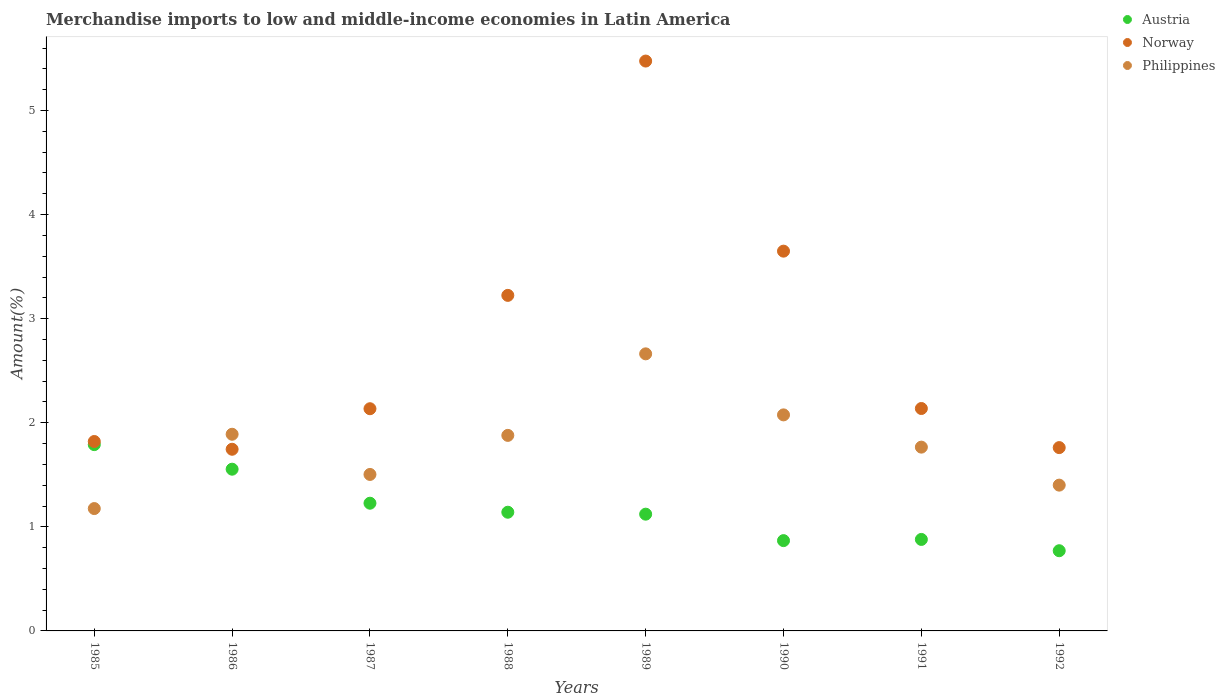Is the number of dotlines equal to the number of legend labels?
Make the answer very short. Yes. What is the percentage of amount earned from merchandise imports in Norway in 1987?
Offer a terse response. 2.13. Across all years, what is the maximum percentage of amount earned from merchandise imports in Philippines?
Offer a terse response. 2.66. Across all years, what is the minimum percentage of amount earned from merchandise imports in Austria?
Give a very brief answer. 0.77. In which year was the percentage of amount earned from merchandise imports in Philippines minimum?
Ensure brevity in your answer.  1985. What is the total percentage of amount earned from merchandise imports in Austria in the graph?
Ensure brevity in your answer.  9.35. What is the difference between the percentage of amount earned from merchandise imports in Norway in 1986 and that in 1990?
Make the answer very short. -1.9. What is the difference between the percentage of amount earned from merchandise imports in Norway in 1985 and the percentage of amount earned from merchandise imports in Philippines in 1988?
Make the answer very short. -0.06. What is the average percentage of amount earned from merchandise imports in Austria per year?
Offer a very short reply. 1.17. In the year 1985, what is the difference between the percentage of amount earned from merchandise imports in Philippines and percentage of amount earned from merchandise imports in Norway?
Offer a very short reply. -0.64. What is the ratio of the percentage of amount earned from merchandise imports in Philippines in 1985 to that in 1992?
Offer a very short reply. 0.84. Is the percentage of amount earned from merchandise imports in Philippines in 1985 less than that in 1988?
Your answer should be compact. Yes. Is the difference between the percentage of amount earned from merchandise imports in Philippines in 1987 and 1990 greater than the difference between the percentage of amount earned from merchandise imports in Norway in 1987 and 1990?
Give a very brief answer. Yes. What is the difference between the highest and the second highest percentage of amount earned from merchandise imports in Philippines?
Provide a short and direct response. 0.59. What is the difference between the highest and the lowest percentage of amount earned from merchandise imports in Norway?
Your answer should be compact. 3.73. Is the sum of the percentage of amount earned from merchandise imports in Austria in 1986 and 1988 greater than the maximum percentage of amount earned from merchandise imports in Philippines across all years?
Give a very brief answer. Yes. Does the percentage of amount earned from merchandise imports in Norway monotonically increase over the years?
Offer a very short reply. No. Is the percentage of amount earned from merchandise imports in Philippines strictly greater than the percentage of amount earned from merchandise imports in Norway over the years?
Provide a short and direct response. No. Is the percentage of amount earned from merchandise imports in Austria strictly less than the percentage of amount earned from merchandise imports in Norway over the years?
Give a very brief answer. Yes. Are the values on the major ticks of Y-axis written in scientific E-notation?
Provide a succinct answer. No. Where does the legend appear in the graph?
Your answer should be compact. Top right. How many legend labels are there?
Ensure brevity in your answer.  3. What is the title of the graph?
Make the answer very short. Merchandise imports to low and middle-income economies in Latin America. Does "Swaziland" appear as one of the legend labels in the graph?
Make the answer very short. No. What is the label or title of the X-axis?
Keep it short and to the point. Years. What is the label or title of the Y-axis?
Offer a very short reply. Amount(%). What is the Amount(%) in Austria in 1985?
Make the answer very short. 1.79. What is the Amount(%) of Norway in 1985?
Offer a very short reply. 1.82. What is the Amount(%) in Philippines in 1985?
Ensure brevity in your answer.  1.18. What is the Amount(%) of Austria in 1986?
Ensure brevity in your answer.  1.55. What is the Amount(%) in Norway in 1986?
Provide a succinct answer. 1.75. What is the Amount(%) of Philippines in 1986?
Provide a short and direct response. 1.89. What is the Amount(%) of Austria in 1987?
Your answer should be compact. 1.23. What is the Amount(%) of Norway in 1987?
Provide a short and direct response. 2.13. What is the Amount(%) of Philippines in 1987?
Your answer should be compact. 1.5. What is the Amount(%) in Austria in 1988?
Give a very brief answer. 1.14. What is the Amount(%) of Norway in 1988?
Offer a terse response. 3.22. What is the Amount(%) of Philippines in 1988?
Give a very brief answer. 1.88. What is the Amount(%) in Austria in 1989?
Your answer should be very brief. 1.12. What is the Amount(%) of Norway in 1989?
Make the answer very short. 5.48. What is the Amount(%) of Philippines in 1989?
Your answer should be very brief. 2.66. What is the Amount(%) in Austria in 1990?
Offer a terse response. 0.87. What is the Amount(%) of Norway in 1990?
Your answer should be compact. 3.65. What is the Amount(%) of Philippines in 1990?
Ensure brevity in your answer.  2.08. What is the Amount(%) in Austria in 1991?
Offer a terse response. 0.88. What is the Amount(%) in Norway in 1991?
Offer a very short reply. 2.14. What is the Amount(%) in Philippines in 1991?
Your answer should be compact. 1.77. What is the Amount(%) of Austria in 1992?
Offer a terse response. 0.77. What is the Amount(%) of Norway in 1992?
Make the answer very short. 1.76. What is the Amount(%) in Philippines in 1992?
Provide a short and direct response. 1.4. Across all years, what is the maximum Amount(%) in Austria?
Give a very brief answer. 1.79. Across all years, what is the maximum Amount(%) of Norway?
Your answer should be very brief. 5.48. Across all years, what is the maximum Amount(%) of Philippines?
Ensure brevity in your answer.  2.66. Across all years, what is the minimum Amount(%) of Austria?
Give a very brief answer. 0.77. Across all years, what is the minimum Amount(%) of Norway?
Provide a short and direct response. 1.75. Across all years, what is the minimum Amount(%) in Philippines?
Provide a short and direct response. 1.18. What is the total Amount(%) of Austria in the graph?
Your response must be concise. 9.35. What is the total Amount(%) in Norway in the graph?
Keep it short and to the point. 21.95. What is the total Amount(%) of Philippines in the graph?
Your answer should be compact. 14.35. What is the difference between the Amount(%) of Austria in 1985 and that in 1986?
Your response must be concise. 0.24. What is the difference between the Amount(%) in Norway in 1985 and that in 1986?
Offer a terse response. 0.07. What is the difference between the Amount(%) of Philippines in 1985 and that in 1986?
Offer a very short reply. -0.71. What is the difference between the Amount(%) of Austria in 1985 and that in 1987?
Offer a terse response. 0.56. What is the difference between the Amount(%) in Norway in 1985 and that in 1987?
Keep it short and to the point. -0.31. What is the difference between the Amount(%) of Philippines in 1985 and that in 1987?
Provide a succinct answer. -0.33. What is the difference between the Amount(%) in Austria in 1985 and that in 1988?
Your answer should be compact. 0.65. What is the difference between the Amount(%) of Norway in 1985 and that in 1988?
Ensure brevity in your answer.  -1.4. What is the difference between the Amount(%) in Philippines in 1985 and that in 1988?
Offer a terse response. -0.7. What is the difference between the Amount(%) of Austria in 1985 and that in 1989?
Offer a terse response. 0.67. What is the difference between the Amount(%) in Norway in 1985 and that in 1989?
Offer a very short reply. -3.66. What is the difference between the Amount(%) of Philippines in 1985 and that in 1989?
Offer a very short reply. -1.49. What is the difference between the Amount(%) of Austria in 1985 and that in 1990?
Give a very brief answer. 0.92. What is the difference between the Amount(%) of Norway in 1985 and that in 1990?
Offer a very short reply. -1.83. What is the difference between the Amount(%) of Philippines in 1985 and that in 1990?
Ensure brevity in your answer.  -0.9. What is the difference between the Amount(%) in Austria in 1985 and that in 1991?
Provide a succinct answer. 0.91. What is the difference between the Amount(%) in Norway in 1985 and that in 1991?
Make the answer very short. -0.32. What is the difference between the Amount(%) of Philippines in 1985 and that in 1991?
Offer a very short reply. -0.59. What is the difference between the Amount(%) in Austria in 1985 and that in 1992?
Offer a very short reply. 1.02. What is the difference between the Amount(%) in Norway in 1985 and that in 1992?
Keep it short and to the point. 0.06. What is the difference between the Amount(%) in Philippines in 1985 and that in 1992?
Provide a succinct answer. -0.23. What is the difference between the Amount(%) of Austria in 1986 and that in 1987?
Your answer should be compact. 0.33. What is the difference between the Amount(%) in Norway in 1986 and that in 1987?
Provide a succinct answer. -0.39. What is the difference between the Amount(%) in Philippines in 1986 and that in 1987?
Your answer should be very brief. 0.39. What is the difference between the Amount(%) of Austria in 1986 and that in 1988?
Give a very brief answer. 0.41. What is the difference between the Amount(%) of Norway in 1986 and that in 1988?
Keep it short and to the point. -1.48. What is the difference between the Amount(%) in Philippines in 1986 and that in 1988?
Make the answer very short. 0.01. What is the difference between the Amount(%) in Austria in 1986 and that in 1989?
Give a very brief answer. 0.43. What is the difference between the Amount(%) in Norway in 1986 and that in 1989?
Provide a succinct answer. -3.73. What is the difference between the Amount(%) of Philippines in 1986 and that in 1989?
Ensure brevity in your answer.  -0.77. What is the difference between the Amount(%) of Austria in 1986 and that in 1990?
Offer a terse response. 0.69. What is the difference between the Amount(%) in Norway in 1986 and that in 1990?
Your answer should be very brief. -1.9. What is the difference between the Amount(%) of Philippines in 1986 and that in 1990?
Your answer should be very brief. -0.19. What is the difference between the Amount(%) in Austria in 1986 and that in 1991?
Make the answer very short. 0.67. What is the difference between the Amount(%) in Norway in 1986 and that in 1991?
Keep it short and to the point. -0.39. What is the difference between the Amount(%) of Philippines in 1986 and that in 1991?
Provide a succinct answer. 0.12. What is the difference between the Amount(%) in Austria in 1986 and that in 1992?
Offer a very short reply. 0.78. What is the difference between the Amount(%) of Norway in 1986 and that in 1992?
Give a very brief answer. -0.02. What is the difference between the Amount(%) of Philippines in 1986 and that in 1992?
Keep it short and to the point. 0.49. What is the difference between the Amount(%) of Austria in 1987 and that in 1988?
Ensure brevity in your answer.  0.09. What is the difference between the Amount(%) in Norway in 1987 and that in 1988?
Ensure brevity in your answer.  -1.09. What is the difference between the Amount(%) of Philippines in 1987 and that in 1988?
Your response must be concise. -0.38. What is the difference between the Amount(%) of Austria in 1987 and that in 1989?
Ensure brevity in your answer.  0.11. What is the difference between the Amount(%) of Norway in 1987 and that in 1989?
Give a very brief answer. -3.34. What is the difference between the Amount(%) of Philippines in 1987 and that in 1989?
Ensure brevity in your answer.  -1.16. What is the difference between the Amount(%) in Austria in 1987 and that in 1990?
Provide a short and direct response. 0.36. What is the difference between the Amount(%) of Norway in 1987 and that in 1990?
Offer a very short reply. -1.51. What is the difference between the Amount(%) of Philippines in 1987 and that in 1990?
Provide a short and direct response. -0.57. What is the difference between the Amount(%) of Austria in 1987 and that in 1991?
Your response must be concise. 0.35. What is the difference between the Amount(%) of Norway in 1987 and that in 1991?
Keep it short and to the point. -0. What is the difference between the Amount(%) of Philippines in 1987 and that in 1991?
Keep it short and to the point. -0.26. What is the difference between the Amount(%) of Austria in 1987 and that in 1992?
Offer a terse response. 0.46. What is the difference between the Amount(%) in Norway in 1987 and that in 1992?
Ensure brevity in your answer.  0.37. What is the difference between the Amount(%) in Philippines in 1987 and that in 1992?
Provide a succinct answer. 0.1. What is the difference between the Amount(%) of Austria in 1988 and that in 1989?
Provide a short and direct response. 0.02. What is the difference between the Amount(%) in Norway in 1988 and that in 1989?
Offer a terse response. -2.25. What is the difference between the Amount(%) of Philippines in 1988 and that in 1989?
Your response must be concise. -0.78. What is the difference between the Amount(%) of Austria in 1988 and that in 1990?
Provide a short and direct response. 0.27. What is the difference between the Amount(%) of Norway in 1988 and that in 1990?
Your answer should be compact. -0.42. What is the difference between the Amount(%) of Philippines in 1988 and that in 1990?
Offer a very short reply. -0.2. What is the difference between the Amount(%) in Austria in 1988 and that in 1991?
Give a very brief answer. 0.26. What is the difference between the Amount(%) in Norway in 1988 and that in 1991?
Provide a short and direct response. 1.09. What is the difference between the Amount(%) of Philippines in 1988 and that in 1991?
Provide a short and direct response. 0.11. What is the difference between the Amount(%) in Austria in 1988 and that in 1992?
Give a very brief answer. 0.37. What is the difference between the Amount(%) in Norway in 1988 and that in 1992?
Keep it short and to the point. 1.46. What is the difference between the Amount(%) of Philippines in 1988 and that in 1992?
Your answer should be compact. 0.48. What is the difference between the Amount(%) of Austria in 1989 and that in 1990?
Your answer should be compact. 0.25. What is the difference between the Amount(%) in Norway in 1989 and that in 1990?
Your answer should be very brief. 1.83. What is the difference between the Amount(%) in Philippines in 1989 and that in 1990?
Ensure brevity in your answer.  0.59. What is the difference between the Amount(%) of Austria in 1989 and that in 1991?
Keep it short and to the point. 0.24. What is the difference between the Amount(%) in Norway in 1989 and that in 1991?
Your response must be concise. 3.34. What is the difference between the Amount(%) in Philippines in 1989 and that in 1991?
Make the answer very short. 0.9. What is the difference between the Amount(%) of Austria in 1989 and that in 1992?
Your answer should be compact. 0.35. What is the difference between the Amount(%) in Norway in 1989 and that in 1992?
Your answer should be very brief. 3.71. What is the difference between the Amount(%) of Philippines in 1989 and that in 1992?
Your response must be concise. 1.26. What is the difference between the Amount(%) in Austria in 1990 and that in 1991?
Offer a very short reply. -0.01. What is the difference between the Amount(%) in Norway in 1990 and that in 1991?
Your answer should be compact. 1.51. What is the difference between the Amount(%) of Philippines in 1990 and that in 1991?
Ensure brevity in your answer.  0.31. What is the difference between the Amount(%) in Austria in 1990 and that in 1992?
Ensure brevity in your answer.  0.1. What is the difference between the Amount(%) of Norway in 1990 and that in 1992?
Your answer should be compact. 1.89. What is the difference between the Amount(%) of Philippines in 1990 and that in 1992?
Offer a very short reply. 0.68. What is the difference between the Amount(%) in Austria in 1991 and that in 1992?
Offer a very short reply. 0.11. What is the difference between the Amount(%) in Norway in 1991 and that in 1992?
Your answer should be very brief. 0.38. What is the difference between the Amount(%) of Philippines in 1991 and that in 1992?
Offer a terse response. 0.37. What is the difference between the Amount(%) of Austria in 1985 and the Amount(%) of Norway in 1986?
Offer a very short reply. 0.04. What is the difference between the Amount(%) of Austria in 1985 and the Amount(%) of Philippines in 1986?
Provide a succinct answer. -0.1. What is the difference between the Amount(%) in Norway in 1985 and the Amount(%) in Philippines in 1986?
Keep it short and to the point. -0.07. What is the difference between the Amount(%) in Austria in 1985 and the Amount(%) in Norway in 1987?
Your response must be concise. -0.34. What is the difference between the Amount(%) in Austria in 1985 and the Amount(%) in Philippines in 1987?
Keep it short and to the point. 0.29. What is the difference between the Amount(%) of Norway in 1985 and the Amount(%) of Philippines in 1987?
Your answer should be very brief. 0.32. What is the difference between the Amount(%) in Austria in 1985 and the Amount(%) in Norway in 1988?
Ensure brevity in your answer.  -1.43. What is the difference between the Amount(%) in Austria in 1985 and the Amount(%) in Philippines in 1988?
Make the answer very short. -0.09. What is the difference between the Amount(%) of Norway in 1985 and the Amount(%) of Philippines in 1988?
Provide a succinct answer. -0.06. What is the difference between the Amount(%) in Austria in 1985 and the Amount(%) in Norway in 1989?
Offer a terse response. -3.69. What is the difference between the Amount(%) of Austria in 1985 and the Amount(%) of Philippines in 1989?
Offer a terse response. -0.87. What is the difference between the Amount(%) in Norway in 1985 and the Amount(%) in Philippines in 1989?
Your answer should be compact. -0.84. What is the difference between the Amount(%) of Austria in 1985 and the Amount(%) of Norway in 1990?
Offer a terse response. -1.86. What is the difference between the Amount(%) of Austria in 1985 and the Amount(%) of Philippines in 1990?
Keep it short and to the point. -0.29. What is the difference between the Amount(%) in Norway in 1985 and the Amount(%) in Philippines in 1990?
Ensure brevity in your answer.  -0.26. What is the difference between the Amount(%) of Austria in 1985 and the Amount(%) of Norway in 1991?
Make the answer very short. -0.35. What is the difference between the Amount(%) in Austria in 1985 and the Amount(%) in Philippines in 1991?
Your response must be concise. 0.02. What is the difference between the Amount(%) in Norway in 1985 and the Amount(%) in Philippines in 1991?
Your answer should be very brief. 0.05. What is the difference between the Amount(%) in Austria in 1985 and the Amount(%) in Norway in 1992?
Provide a short and direct response. 0.03. What is the difference between the Amount(%) of Austria in 1985 and the Amount(%) of Philippines in 1992?
Make the answer very short. 0.39. What is the difference between the Amount(%) in Norway in 1985 and the Amount(%) in Philippines in 1992?
Offer a terse response. 0.42. What is the difference between the Amount(%) of Austria in 1986 and the Amount(%) of Norway in 1987?
Make the answer very short. -0.58. What is the difference between the Amount(%) in Austria in 1986 and the Amount(%) in Philippines in 1987?
Keep it short and to the point. 0.05. What is the difference between the Amount(%) of Norway in 1986 and the Amount(%) of Philippines in 1987?
Provide a short and direct response. 0.24. What is the difference between the Amount(%) in Austria in 1986 and the Amount(%) in Norway in 1988?
Offer a terse response. -1.67. What is the difference between the Amount(%) in Austria in 1986 and the Amount(%) in Philippines in 1988?
Keep it short and to the point. -0.32. What is the difference between the Amount(%) in Norway in 1986 and the Amount(%) in Philippines in 1988?
Give a very brief answer. -0.13. What is the difference between the Amount(%) in Austria in 1986 and the Amount(%) in Norway in 1989?
Your answer should be compact. -3.92. What is the difference between the Amount(%) of Austria in 1986 and the Amount(%) of Philippines in 1989?
Provide a succinct answer. -1.11. What is the difference between the Amount(%) of Norway in 1986 and the Amount(%) of Philippines in 1989?
Keep it short and to the point. -0.92. What is the difference between the Amount(%) of Austria in 1986 and the Amount(%) of Norway in 1990?
Provide a short and direct response. -2.09. What is the difference between the Amount(%) of Austria in 1986 and the Amount(%) of Philippines in 1990?
Provide a short and direct response. -0.52. What is the difference between the Amount(%) of Norway in 1986 and the Amount(%) of Philippines in 1990?
Ensure brevity in your answer.  -0.33. What is the difference between the Amount(%) of Austria in 1986 and the Amount(%) of Norway in 1991?
Provide a succinct answer. -0.58. What is the difference between the Amount(%) of Austria in 1986 and the Amount(%) of Philippines in 1991?
Offer a very short reply. -0.21. What is the difference between the Amount(%) of Norway in 1986 and the Amount(%) of Philippines in 1991?
Make the answer very short. -0.02. What is the difference between the Amount(%) in Austria in 1986 and the Amount(%) in Norway in 1992?
Provide a succinct answer. -0.21. What is the difference between the Amount(%) in Austria in 1986 and the Amount(%) in Philippines in 1992?
Ensure brevity in your answer.  0.15. What is the difference between the Amount(%) in Norway in 1986 and the Amount(%) in Philippines in 1992?
Keep it short and to the point. 0.34. What is the difference between the Amount(%) in Austria in 1987 and the Amount(%) in Norway in 1988?
Your answer should be compact. -2. What is the difference between the Amount(%) of Austria in 1987 and the Amount(%) of Philippines in 1988?
Keep it short and to the point. -0.65. What is the difference between the Amount(%) in Norway in 1987 and the Amount(%) in Philippines in 1988?
Make the answer very short. 0.26. What is the difference between the Amount(%) of Austria in 1987 and the Amount(%) of Norway in 1989?
Your answer should be very brief. -4.25. What is the difference between the Amount(%) of Austria in 1987 and the Amount(%) of Philippines in 1989?
Provide a short and direct response. -1.44. What is the difference between the Amount(%) in Norway in 1987 and the Amount(%) in Philippines in 1989?
Your answer should be very brief. -0.53. What is the difference between the Amount(%) of Austria in 1987 and the Amount(%) of Norway in 1990?
Give a very brief answer. -2.42. What is the difference between the Amount(%) in Austria in 1987 and the Amount(%) in Philippines in 1990?
Give a very brief answer. -0.85. What is the difference between the Amount(%) in Norway in 1987 and the Amount(%) in Philippines in 1990?
Offer a very short reply. 0.06. What is the difference between the Amount(%) in Austria in 1987 and the Amount(%) in Norway in 1991?
Offer a very short reply. -0.91. What is the difference between the Amount(%) in Austria in 1987 and the Amount(%) in Philippines in 1991?
Provide a short and direct response. -0.54. What is the difference between the Amount(%) in Norway in 1987 and the Amount(%) in Philippines in 1991?
Ensure brevity in your answer.  0.37. What is the difference between the Amount(%) of Austria in 1987 and the Amount(%) of Norway in 1992?
Provide a succinct answer. -0.53. What is the difference between the Amount(%) in Austria in 1987 and the Amount(%) in Philippines in 1992?
Your answer should be very brief. -0.17. What is the difference between the Amount(%) of Norway in 1987 and the Amount(%) of Philippines in 1992?
Offer a terse response. 0.73. What is the difference between the Amount(%) in Austria in 1988 and the Amount(%) in Norway in 1989?
Ensure brevity in your answer.  -4.33. What is the difference between the Amount(%) of Austria in 1988 and the Amount(%) of Philippines in 1989?
Make the answer very short. -1.52. What is the difference between the Amount(%) of Norway in 1988 and the Amount(%) of Philippines in 1989?
Make the answer very short. 0.56. What is the difference between the Amount(%) in Austria in 1988 and the Amount(%) in Norway in 1990?
Give a very brief answer. -2.51. What is the difference between the Amount(%) of Austria in 1988 and the Amount(%) of Philippines in 1990?
Offer a very short reply. -0.94. What is the difference between the Amount(%) of Norway in 1988 and the Amount(%) of Philippines in 1990?
Your response must be concise. 1.15. What is the difference between the Amount(%) in Austria in 1988 and the Amount(%) in Norway in 1991?
Give a very brief answer. -1. What is the difference between the Amount(%) in Austria in 1988 and the Amount(%) in Philippines in 1991?
Give a very brief answer. -0.63. What is the difference between the Amount(%) in Norway in 1988 and the Amount(%) in Philippines in 1991?
Offer a terse response. 1.46. What is the difference between the Amount(%) of Austria in 1988 and the Amount(%) of Norway in 1992?
Your answer should be compact. -0.62. What is the difference between the Amount(%) in Austria in 1988 and the Amount(%) in Philippines in 1992?
Ensure brevity in your answer.  -0.26. What is the difference between the Amount(%) in Norway in 1988 and the Amount(%) in Philippines in 1992?
Your answer should be compact. 1.82. What is the difference between the Amount(%) of Austria in 1989 and the Amount(%) of Norway in 1990?
Make the answer very short. -2.53. What is the difference between the Amount(%) of Austria in 1989 and the Amount(%) of Philippines in 1990?
Offer a very short reply. -0.95. What is the difference between the Amount(%) in Norway in 1989 and the Amount(%) in Philippines in 1990?
Provide a short and direct response. 3.4. What is the difference between the Amount(%) of Austria in 1989 and the Amount(%) of Norway in 1991?
Ensure brevity in your answer.  -1.02. What is the difference between the Amount(%) in Austria in 1989 and the Amount(%) in Philippines in 1991?
Your response must be concise. -0.64. What is the difference between the Amount(%) of Norway in 1989 and the Amount(%) of Philippines in 1991?
Offer a very short reply. 3.71. What is the difference between the Amount(%) in Austria in 1989 and the Amount(%) in Norway in 1992?
Your response must be concise. -0.64. What is the difference between the Amount(%) in Austria in 1989 and the Amount(%) in Philippines in 1992?
Keep it short and to the point. -0.28. What is the difference between the Amount(%) of Norway in 1989 and the Amount(%) of Philippines in 1992?
Ensure brevity in your answer.  4.07. What is the difference between the Amount(%) of Austria in 1990 and the Amount(%) of Norway in 1991?
Keep it short and to the point. -1.27. What is the difference between the Amount(%) of Austria in 1990 and the Amount(%) of Philippines in 1991?
Keep it short and to the point. -0.9. What is the difference between the Amount(%) in Norway in 1990 and the Amount(%) in Philippines in 1991?
Your answer should be compact. 1.88. What is the difference between the Amount(%) in Austria in 1990 and the Amount(%) in Norway in 1992?
Provide a short and direct response. -0.89. What is the difference between the Amount(%) in Austria in 1990 and the Amount(%) in Philippines in 1992?
Keep it short and to the point. -0.53. What is the difference between the Amount(%) of Norway in 1990 and the Amount(%) of Philippines in 1992?
Make the answer very short. 2.25. What is the difference between the Amount(%) of Austria in 1991 and the Amount(%) of Norway in 1992?
Your response must be concise. -0.88. What is the difference between the Amount(%) of Austria in 1991 and the Amount(%) of Philippines in 1992?
Provide a short and direct response. -0.52. What is the difference between the Amount(%) in Norway in 1991 and the Amount(%) in Philippines in 1992?
Your answer should be compact. 0.74. What is the average Amount(%) of Austria per year?
Your answer should be very brief. 1.17. What is the average Amount(%) in Norway per year?
Provide a succinct answer. 2.74. What is the average Amount(%) in Philippines per year?
Offer a terse response. 1.79. In the year 1985, what is the difference between the Amount(%) in Austria and Amount(%) in Norway?
Offer a very short reply. -0.03. In the year 1985, what is the difference between the Amount(%) of Austria and Amount(%) of Philippines?
Provide a succinct answer. 0.61. In the year 1985, what is the difference between the Amount(%) of Norway and Amount(%) of Philippines?
Your response must be concise. 0.64. In the year 1986, what is the difference between the Amount(%) in Austria and Amount(%) in Norway?
Make the answer very short. -0.19. In the year 1986, what is the difference between the Amount(%) in Austria and Amount(%) in Philippines?
Give a very brief answer. -0.34. In the year 1986, what is the difference between the Amount(%) in Norway and Amount(%) in Philippines?
Your answer should be compact. -0.14. In the year 1987, what is the difference between the Amount(%) of Austria and Amount(%) of Norway?
Offer a very short reply. -0.91. In the year 1987, what is the difference between the Amount(%) of Austria and Amount(%) of Philippines?
Offer a terse response. -0.28. In the year 1987, what is the difference between the Amount(%) in Norway and Amount(%) in Philippines?
Your answer should be compact. 0.63. In the year 1988, what is the difference between the Amount(%) of Austria and Amount(%) of Norway?
Make the answer very short. -2.08. In the year 1988, what is the difference between the Amount(%) of Austria and Amount(%) of Philippines?
Offer a very short reply. -0.74. In the year 1988, what is the difference between the Amount(%) of Norway and Amount(%) of Philippines?
Offer a terse response. 1.35. In the year 1989, what is the difference between the Amount(%) in Austria and Amount(%) in Norway?
Make the answer very short. -4.35. In the year 1989, what is the difference between the Amount(%) of Austria and Amount(%) of Philippines?
Your answer should be compact. -1.54. In the year 1989, what is the difference between the Amount(%) of Norway and Amount(%) of Philippines?
Your answer should be very brief. 2.81. In the year 1990, what is the difference between the Amount(%) of Austria and Amount(%) of Norway?
Your answer should be compact. -2.78. In the year 1990, what is the difference between the Amount(%) in Austria and Amount(%) in Philippines?
Offer a terse response. -1.21. In the year 1990, what is the difference between the Amount(%) of Norway and Amount(%) of Philippines?
Provide a succinct answer. 1.57. In the year 1991, what is the difference between the Amount(%) of Austria and Amount(%) of Norway?
Your answer should be very brief. -1.26. In the year 1991, what is the difference between the Amount(%) of Austria and Amount(%) of Philippines?
Ensure brevity in your answer.  -0.89. In the year 1991, what is the difference between the Amount(%) in Norway and Amount(%) in Philippines?
Your response must be concise. 0.37. In the year 1992, what is the difference between the Amount(%) in Austria and Amount(%) in Norway?
Your answer should be very brief. -0.99. In the year 1992, what is the difference between the Amount(%) of Austria and Amount(%) of Philippines?
Your answer should be compact. -0.63. In the year 1992, what is the difference between the Amount(%) in Norway and Amount(%) in Philippines?
Offer a terse response. 0.36. What is the ratio of the Amount(%) of Austria in 1985 to that in 1986?
Provide a short and direct response. 1.15. What is the ratio of the Amount(%) in Norway in 1985 to that in 1986?
Keep it short and to the point. 1.04. What is the ratio of the Amount(%) in Philippines in 1985 to that in 1986?
Your response must be concise. 0.62. What is the ratio of the Amount(%) of Austria in 1985 to that in 1987?
Your response must be concise. 1.46. What is the ratio of the Amount(%) in Norway in 1985 to that in 1987?
Your response must be concise. 0.85. What is the ratio of the Amount(%) of Philippines in 1985 to that in 1987?
Offer a very short reply. 0.78. What is the ratio of the Amount(%) of Austria in 1985 to that in 1988?
Your answer should be compact. 1.57. What is the ratio of the Amount(%) in Norway in 1985 to that in 1988?
Offer a very short reply. 0.56. What is the ratio of the Amount(%) of Philippines in 1985 to that in 1988?
Ensure brevity in your answer.  0.63. What is the ratio of the Amount(%) in Austria in 1985 to that in 1989?
Keep it short and to the point. 1.6. What is the ratio of the Amount(%) of Norway in 1985 to that in 1989?
Keep it short and to the point. 0.33. What is the ratio of the Amount(%) of Philippines in 1985 to that in 1989?
Keep it short and to the point. 0.44. What is the ratio of the Amount(%) in Austria in 1985 to that in 1990?
Offer a terse response. 2.06. What is the ratio of the Amount(%) in Norway in 1985 to that in 1990?
Your answer should be compact. 0.5. What is the ratio of the Amount(%) of Philippines in 1985 to that in 1990?
Give a very brief answer. 0.57. What is the ratio of the Amount(%) of Austria in 1985 to that in 1991?
Your answer should be very brief. 2.04. What is the ratio of the Amount(%) in Norway in 1985 to that in 1991?
Make the answer very short. 0.85. What is the ratio of the Amount(%) of Philippines in 1985 to that in 1991?
Offer a terse response. 0.67. What is the ratio of the Amount(%) in Austria in 1985 to that in 1992?
Your response must be concise. 2.32. What is the ratio of the Amount(%) of Philippines in 1985 to that in 1992?
Your answer should be very brief. 0.84. What is the ratio of the Amount(%) of Austria in 1986 to that in 1987?
Provide a succinct answer. 1.27. What is the ratio of the Amount(%) in Norway in 1986 to that in 1987?
Offer a terse response. 0.82. What is the ratio of the Amount(%) in Philippines in 1986 to that in 1987?
Your response must be concise. 1.26. What is the ratio of the Amount(%) in Austria in 1986 to that in 1988?
Your answer should be very brief. 1.36. What is the ratio of the Amount(%) in Norway in 1986 to that in 1988?
Make the answer very short. 0.54. What is the ratio of the Amount(%) in Philippines in 1986 to that in 1988?
Your response must be concise. 1.01. What is the ratio of the Amount(%) of Austria in 1986 to that in 1989?
Your answer should be very brief. 1.39. What is the ratio of the Amount(%) in Norway in 1986 to that in 1989?
Give a very brief answer. 0.32. What is the ratio of the Amount(%) of Philippines in 1986 to that in 1989?
Your answer should be very brief. 0.71. What is the ratio of the Amount(%) of Austria in 1986 to that in 1990?
Your answer should be compact. 1.79. What is the ratio of the Amount(%) of Norway in 1986 to that in 1990?
Provide a short and direct response. 0.48. What is the ratio of the Amount(%) of Philippines in 1986 to that in 1990?
Give a very brief answer. 0.91. What is the ratio of the Amount(%) in Austria in 1986 to that in 1991?
Offer a terse response. 1.77. What is the ratio of the Amount(%) in Norway in 1986 to that in 1991?
Keep it short and to the point. 0.82. What is the ratio of the Amount(%) of Philippines in 1986 to that in 1991?
Offer a very short reply. 1.07. What is the ratio of the Amount(%) in Austria in 1986 to that in 1992?
Offer a very short reply. 2.02. What is the ratio of the Amount(%) of Norway in 1986 to that in 1992?
Provide a short and direct response. 0.99. What is the ratio of the Amount(%) in Philippines in 1986 to that in 1992?
Keep it short and to the point. 1.35. What is the ratio of the Amount(%) in Austria in 1987 to that in 1988?
Your answer should be compact. 1.08. What is the ratio of the Amount(%) of Norway in 1987 to that in 1988?
Your answer should be compact. 0.66. What is the ratio of the Amount(%) in Philippines in 1987 to that in 1988?
Offer a very short reply. 0.8. What is the ratio of the Amount(%) of Austria in 1987 to that in 1989?
Your answer should be very brief. 1.09. What is the ratio of the Amount(%) in Norway in 1987 to that in 1989?
Give a very brief answer. 0.39. What is the ratio of the Amount(%) of Philippines in 1987 to that in 1989?
Offer a very short reply. 0.56. What is the ratio of the Amount(%) in Austria in 1987 to that in 1990?
Offer a very short reply. 1.41. What is the ratio of the Amount(%) in Norway in 1987 to that in 1990?
Your response must be concise. 0.59. What is the ratio of the Amount(%) of Philippines in 1987 to that in 1990?
Provide a succinct answer. 0.72. What is the ratio of the Amount(%) of Austria in 1987 to that in 1991?
Ensure brevity in your answer.  1.4. What is the ratio of the Amount(%) of Philippines in 1987 to that in 1991?
Provide a short and direct response. 0.85. What is the ratio of the Amount(%) in Austria in 1987 to that in 1992?
Give a very brief answer. 1.59. What is the ratio of the Amount(%) in Norway in 1987 to that in 1992?
Your answer should be very brief. 1.21. What is the ratio of the Amount(%) in Philippines in 1987 to that in 1992?
Ensure brevity in your answer.  1.07. What is the ratio of the Amount(%) in Austria in 1988 to that in 1989?
Provide a succinct answer. 1.02. What is the ratio of the Amount(%) of Norway in 1988 to that in 1989?
Offer a terse response. 0.59. What is the ratio of the Amount(%) in Philippines in 1988 to that in 1989?
Your answer should be very brief. 0.71. What is the ratio of the Amount(%) in Austria in 1988 to that in 1990?
Offer a terse response. 1.31. What is the ratio of the Amount(%) of Norway in 1988 to that in 1990?
Make the answer very short. 0.88. What is the ratio of the Amount(%) in Philippines in 1988 to that in 1990?
Provide a short and direct response. 0.91. What is the ratio of the Amount(%) in Austria in 1988 to that in 1991?
Offer a terse response. 1.3. What is the ratio of the Amount(%) of Norway in 1988 to that in 1991?
Provide a short and direct response. 1.51. What is the ratio of the Amount(%) in Philippines in 1988 to that in 1991?
Give a very brief answer. 1.06. What is the ratio of the Amount(%) of Austria in 1988 to that in 1992?
Your answer should be compact. 1.48. What is the ratio of the Amount(%) of Norway in 1988 to that in 1992?
Offer a very short reply. 1.83. What is the ratio of the Amount(%) in Philippines in 1988 to that in 1992?
Your response must be concise. 1.34. What is the ratio of the Amount(%) in Austria in 1989 to that in 1990?
Offer a terse response. 1.29. What is the ratio of the Amount(%) of Norway in 1989 to that in 1990?
Your response must be concise. 1.5. What is the ratio of the Amount(%) of Philippines in 1989 to that in 1990?
Your answer should be compact. 1.28. What is the ratio of the Amount(%) of Austria in 1989 to that in 1991?
Offer a terse response. 1.28. What is the ratio of the Amount(%) in Norway in 1989 to that in 1991?
Ensure brevity in your answer.  2.56. What is the ratio of the Amount(%) of Philippines in 1989 to that in 1991?
Give a very brief answer. 1.51. What is the ratio of the Amount(%) of Austria in 1989 to that in 1992?
Make the answer very short. 1.46. What is the ratio of the Amount(%) in Norway in 1989 to that in 1992?
Provide a succinct answer. 3.11. What is the ratio of the Amount(%) of Philippines in 1989 to that in 1992?
Offer a very short reply. 1.9. What is the ratio of the Amount(%) of Austria in 1990 to that in 1991?
Provide a short and direct response. 0.99. What is the ratio of the Amount(%) in Norway in 1990 to that in 1991?
Make the answer very short. 1.71. What is the ratio of the Amount(%) in Philippines in 1990 to that in 1991?
Offer a terse response. 1.18. What is the ratio of the Amount(%) of Austria in 1990 to that in 1992?
Offer a very short reply. 1.13. What is the ratio of the Amount(%) in Norway in 1990 to that in 1992?
Keep it short and to the point. 2.07. What is the ratio of the Amount(%) of Philippines in 1990 to that in 1992?
Offer a terse response. 1.48. What is the ratio of the Amount(%) of Austria in 1991 to that in 1992?
Your answer should be compact. 1.14. What is the ratio of the Amount(%) of Norway in 1991 to that in 1992?
Ensure brevity in your answer.  1.21. What is the ratio of the Amount(%) of Philippines in 1991 to that in 1992?
Offer a very short reply. 1.26. What is the difference between the highest and the second highest Amount(%) in Austria?
Make the answer very short. 0.24. What is the difference between the highest and the second highest Amount(%) of Norway?
Your answer should be compact. 1.83. What is the difference between the highest and the second highest Amount(%) of Philippines?
Your response must be concise. 0.59. What is the difference between the highest and the lowest Amount(%) in Austria?
Offer a very short reply. 1.02. What is the difference between the highest and the lowest Amount(%) of Norway?
Ensure brevity in your answer.  3.73. What is the difference between the highest and the lowest Amount(%) of Philippines?
Your response must be concise. 1.49. 